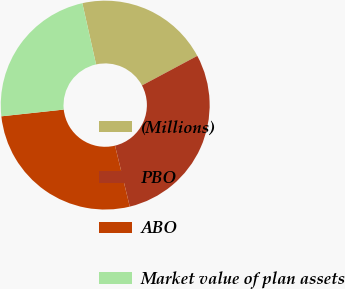<chart> <loc_0><loc_0><loc_500><loc_500><pie_chart><fcel>(Millions)<fcel>PBO<fcel>ABO<fcel>Market value of plan assets<nl><fcel>20.7%<fcel>29.03%<fcel>27.07%<fcel>23.2%<nl></chart> 